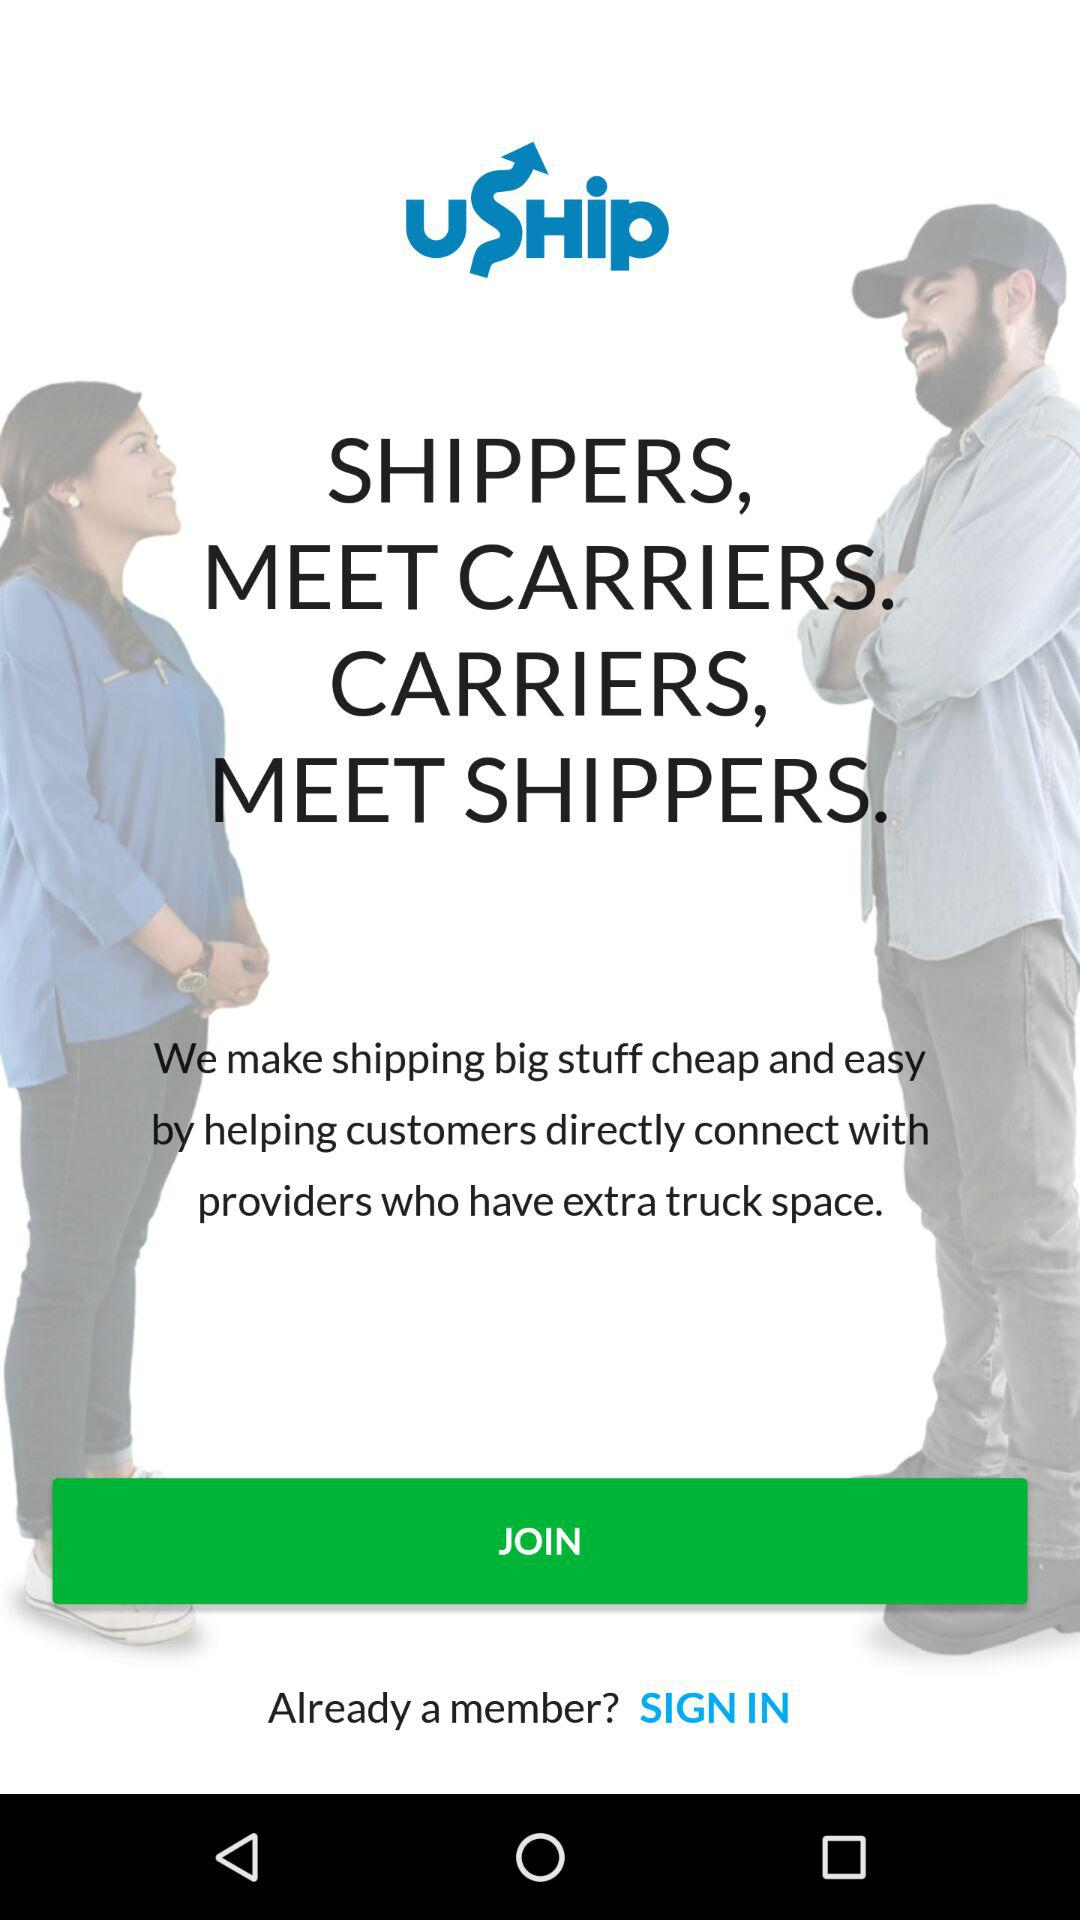What is the name of the application? The name of the application is "uShip". 